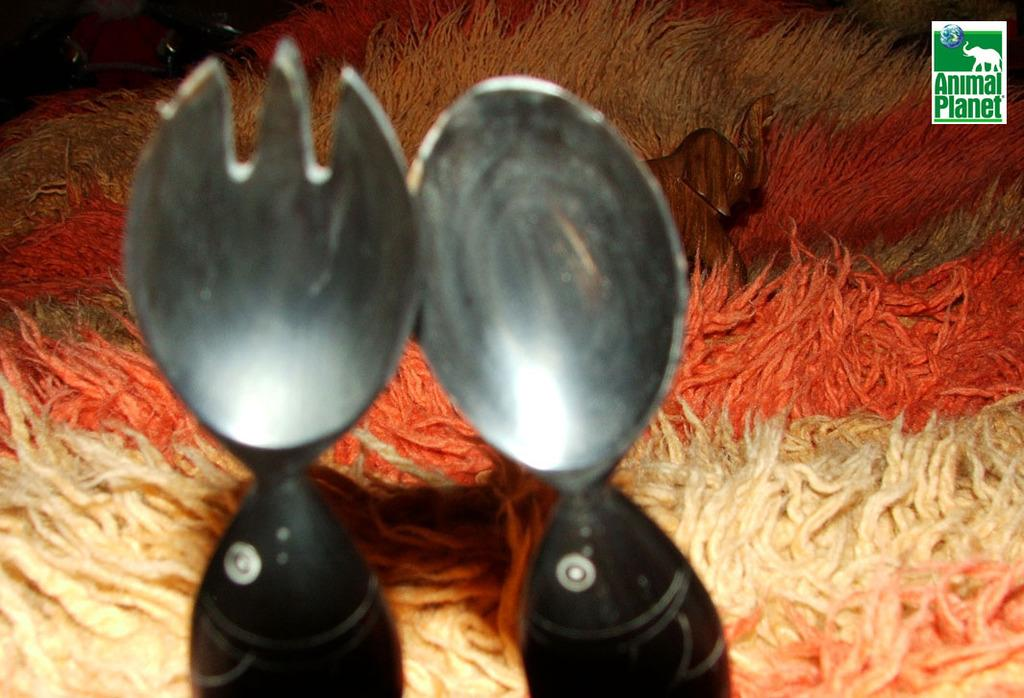What utensils can be seen in the image? There is a spoon and a fork in the image. What type of cloth is present in the image? There is a woolen cloth with an image of an elephant in the image. Where is the logo located in the image? The logo is in the top right corner of the image. How does the bean feel in the image? There is no bean present in the image, so it is not possible to determine how it might feel. 